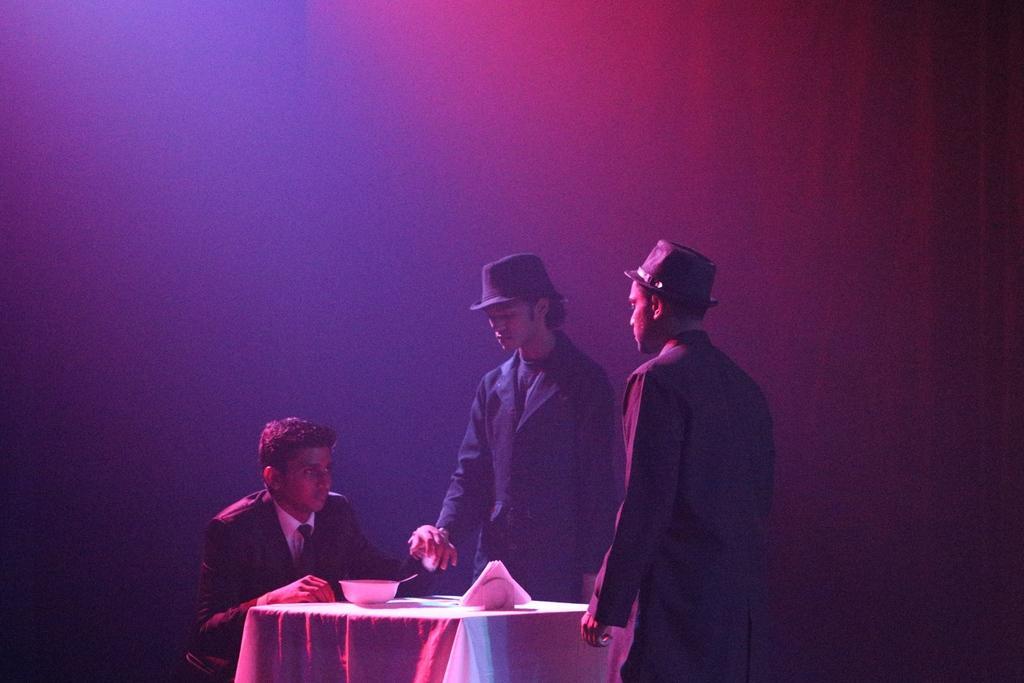Could you give a brief overview of what you see in this image? In this picture I can see 3 men in front and I see that they're wearing formal dress. I can also see that the man on the left is sitting and rest of them are standing and I can see a table in front of them, on which there is a bowl and other thing. I see that it is colorful in the background. 